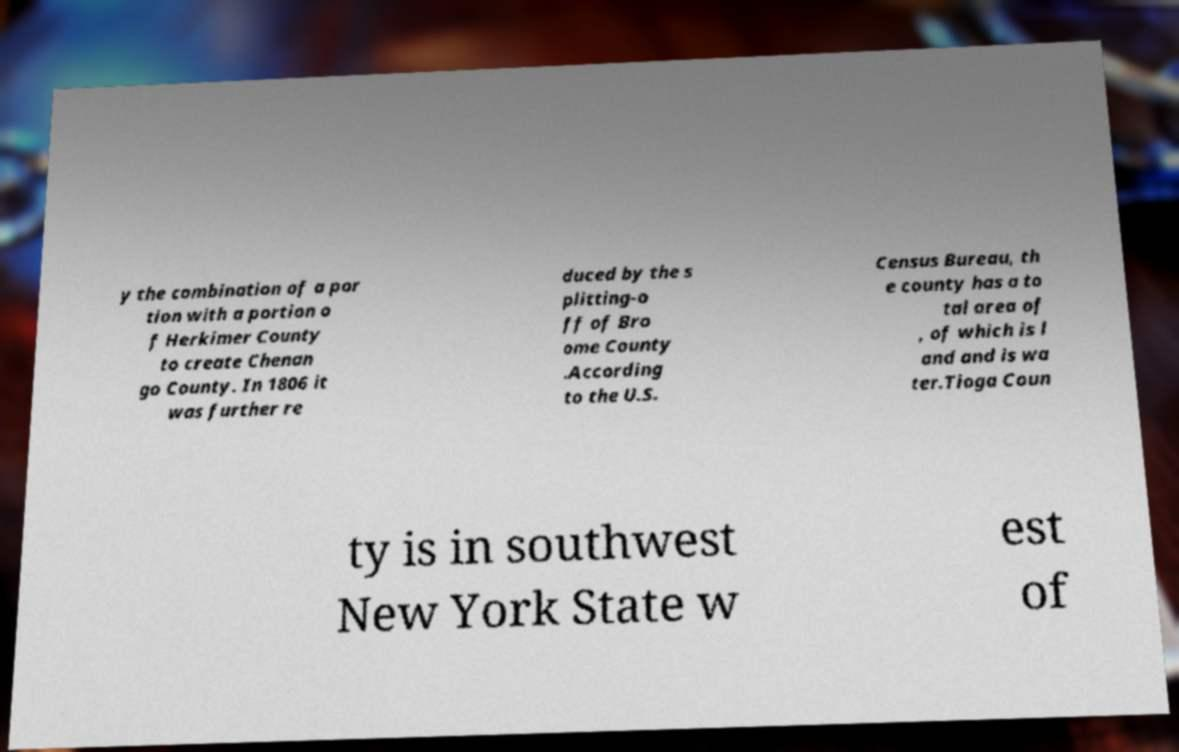Please read and relay the text visible in this image. What does it say? y the combination of a por tion with a portion o f Herkimer County to create Chenan go County. In 1806 it was further re duced by the s plitting-o ff of Bro ome County .According to the U.S. Census Bureau, th e county has a to tal area of , of which is l and and is wa ter.Tioga Coun ty is in southwest New York State w est of 